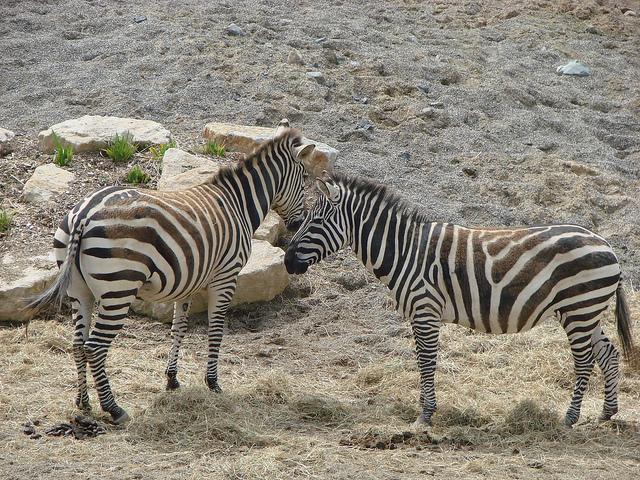Which way to the zebras' back leg joints face?
Give a very brief answer. Left. Are there any plants in this picture?
Be succinct. Yes. What made the dents in the sand?
Quick response, please. Hooves. How many zebras are there?
Keep it brief. 2. Are the zebras running?
Concise answer only. No. Are they facing each other?
Answer briefly. Yes. Is the zebra feasting on grass?
Answer briefly. No. Which zebra is older?
Give a very brief answer. Left. Are these animals facing the same direction?
Write a very short answer. No. How many stripes does these animal?
Quick response, please. Many. How many animals are there?
Keep it brief. 2. What color are the rocks?
Keep it brief. Gray. 